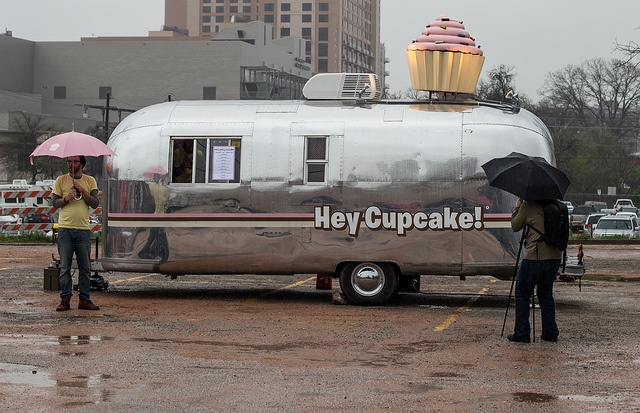Describe the objects in this image and their specific colors. I can see people in lightgray, black, and gray tones, people in lightgray, black, olive, and gray tones, umbrella in lightgray, black, and gray tones, umbrella in lightgray, lightpink, pink, and black tones, and backpack in lightgray, black, and gray tones in this image. 